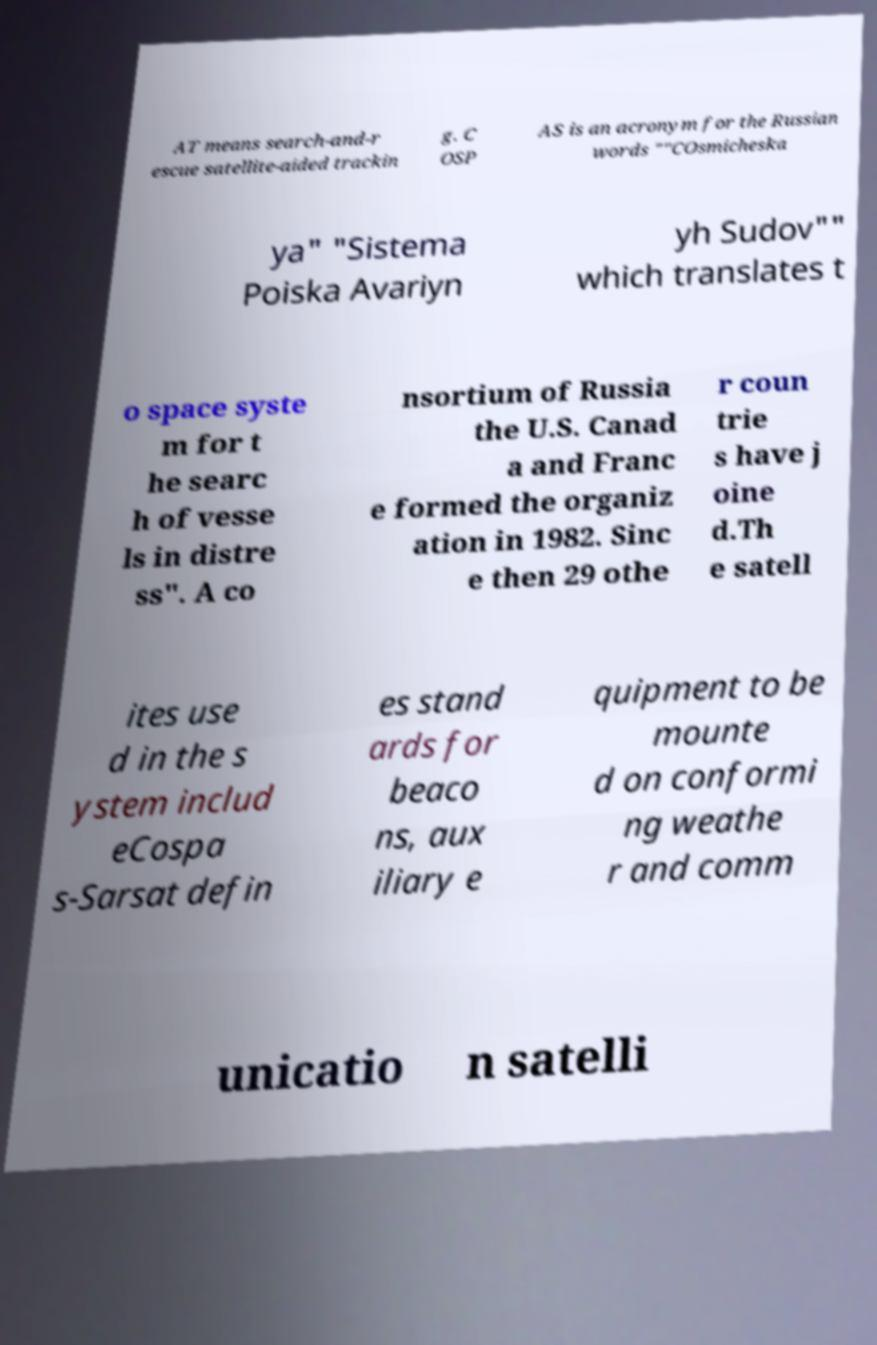Could you assist in decoding the text presented in this image and type it out clearly? AT means search-and-r escue satellite-aided trackin g. C OSP AS is an acronym for the Russian words ""COsmicheska ya" "Sistema Poiska Avariyn yh Sudov"" which translates t o space syste m for t he searc h of vesse ls in distre ss". A co nsortium of Russia the U.S. Canad a and Franc e formed the organiz ation in 1982. Sinc e then 29 othe r coun trie s have j oine d.Th e satell ites use d in the s ystem includ eCospa s-Sarsat defin es stand ards for beaco ns, aux iliary e quipment to be mounte d on conformi ng weathe r and comm unicatio n satelli 